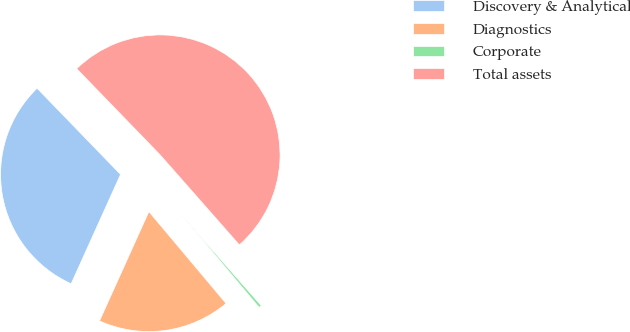<chart> <loc_0><loc_0><loc_500><loc_500><pie_chart><fcel>Discovery & Analytical<fcel>Diagnostics<fcel>Corporate<fcel>Total assets<nl><fcel>31.01%<fcel>17.87%<fcel>0.37%<fcel>50.76%<nl></chart> 